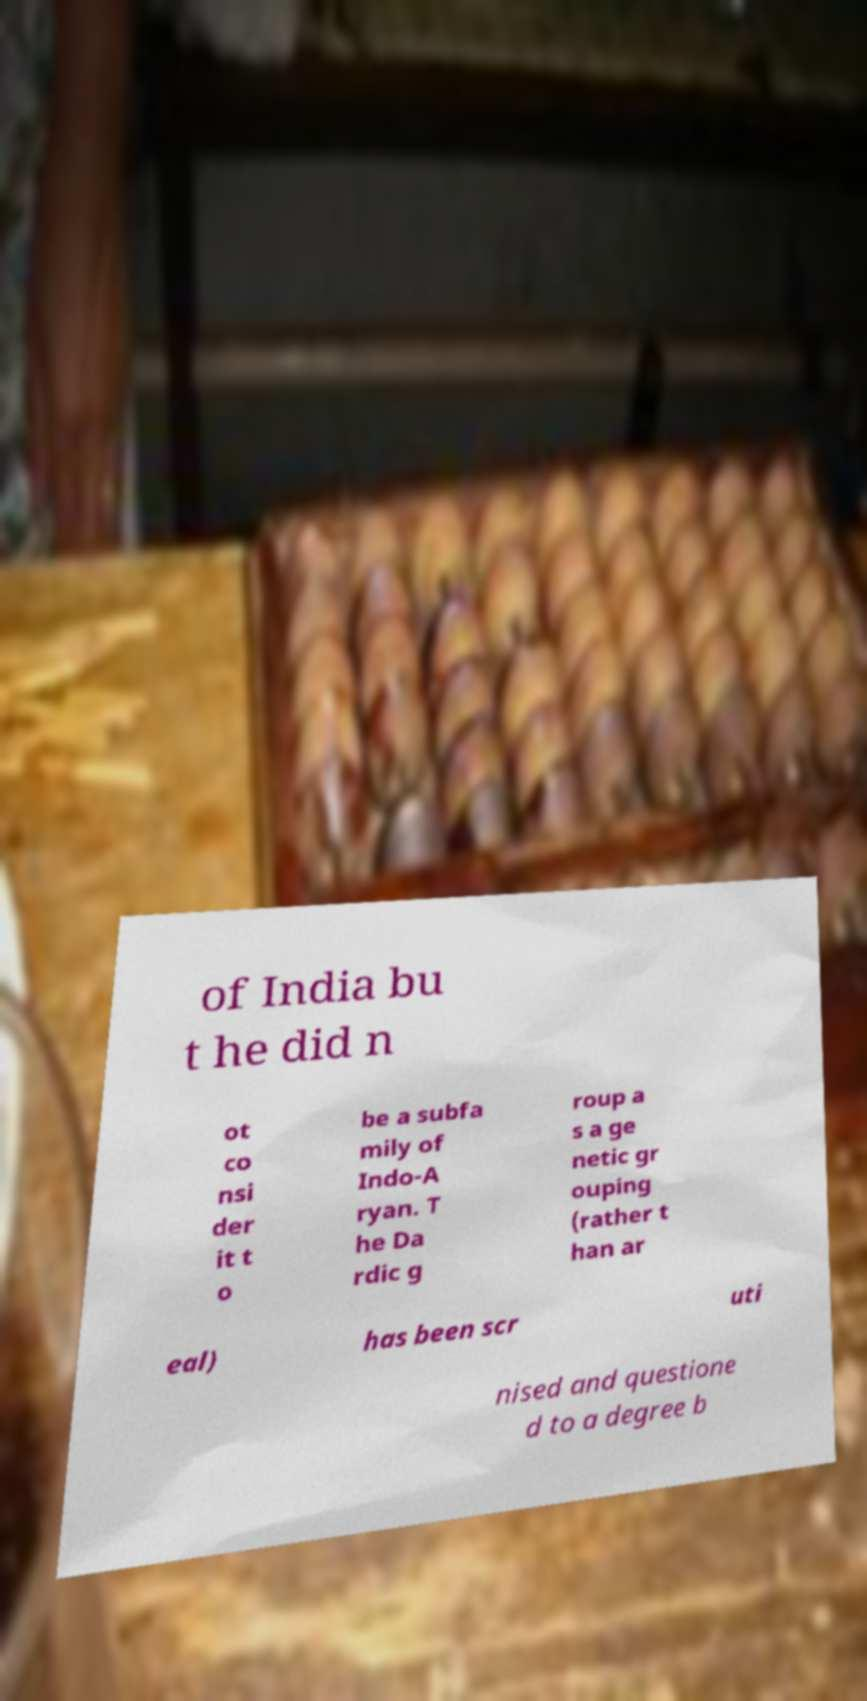Can you accurately transcribe the text from the provided image for me? of India bu t he did n ot co nsi der it t o be a subfa mily of Indo-A ryan. T he Da rdic g roup a s a ge netic gr ouping (rather t han ar eal) has been scr uti nised and questione d to a degree b 